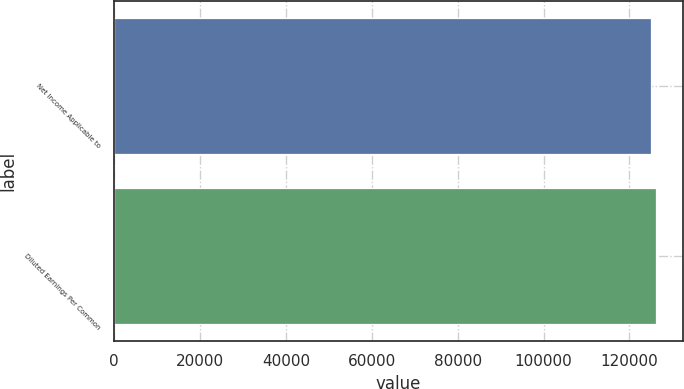Convert chart to OTSL. <chart><loc_0><loc_0><loc_500><loc_500><bar_chart><fcel>Net Income Applicable to<fcel>Diluted Earnings Per Common<nl><fcel>124942<fcel>126130<nl></chart> 